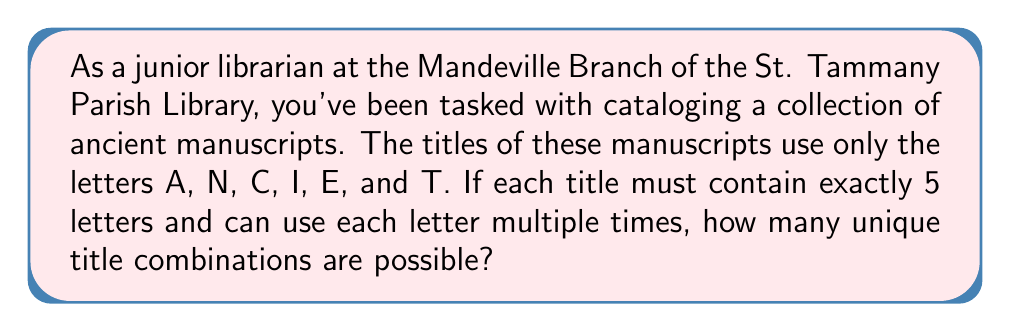What is the answer to this math problem? To solve this problem, we need to use the fundamental counting principle. Here's a step-by-step explanation:

1) We have 6 choices for each letter position (A, N, C, I, E, T).
2) The title must be exactly 5 letters long.
3) We can use each letter multiple times, so our choices don't decrease as we fill in each position.
4) For each position, we have 6 choices, and we need to fill 5 positions.

Therefore, we can calculate the total number of possible combinations as follows:

$$ \text{Total combinations} = 6 \times 6 \times 6 \times 6 \times 6 = 6^5 $$

We can calculate this:

$$ 6^5 = 6 \times 6 \times 6 \times 6 \times 6 = 7,776 $$

This means there are 7,776 possible unique title combinations for the ancient manuscripts using these constraints.
Answer: 7,776 unique title combinations 